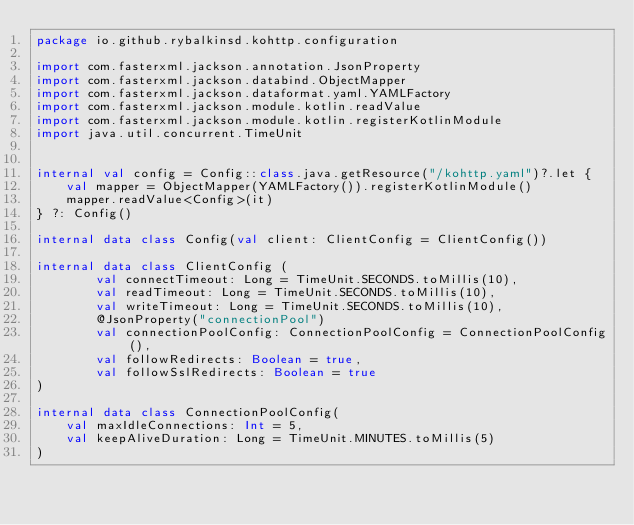<code> <loc_0><loc_0><loc_500><loc_500><_Kotlin_>package io.github.rybalkinsd.kohttp.configuration

import com.fasterxml.jackson.annotation.JsonProperty
import com.fasterxml.jackson.databind.ObjectMapper
import com.fasterxml.jackson.dataformat.yaml.YAMLFactory
import com.fasterxml.jackson.module.kotlin.readValue
import com.fasterxml.jackson.module.kotlin.registerKotlinModule
import java.util.concurrent.TimeUnit


internal val config = Config::class.java.getResource("/kohttp.yaml")?.let {
    val mapper = ObjectMapper(YAMLFactory()).registerKotlinModule()
    mapper.readValue<Config>(it)
} ?: Config()

internal data class Config(val client: ClientConfig = ClientConfig())

internal data class ClientConfig (
        val connectTimeout: Long = TimeUnit.SECONDS.toMillis(10),
        val readTimeout: Long = TimeUnit.SECONDS.toMillis(10),
        val writeTimeout: Long = TimeUnit.SECONDS.toMillis(10),
        @JsonProperty("connectionPool")
        val connectionPoolConfig: ConnectionPoolConfig = ConnectionPoolConfig(),
        val followRedirects: Boolean = true,
        val followSslRedirects: Boolean = true
)

internal data class ConnectionPoolConfig(
    val maxIdleConnections: Int = 5,
    val keepAliveDuration: Long = TimeUnit.MINUTES.toMillis(5)
)


</code> 